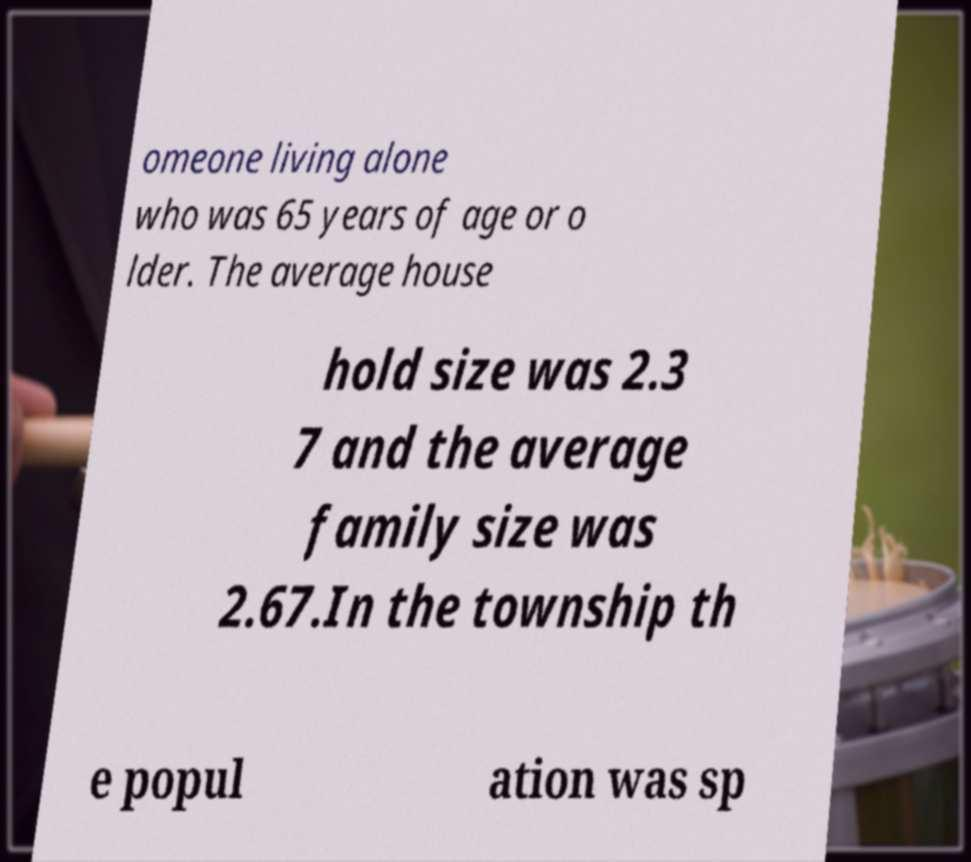What messages or text are displayed in this image? I need them in a readable, typed format. omeone living alone who was 65 years of age or o lder. The average house hold size was 2.3 7 and the average family size was 2.67.In the township th e popul ation was sp 